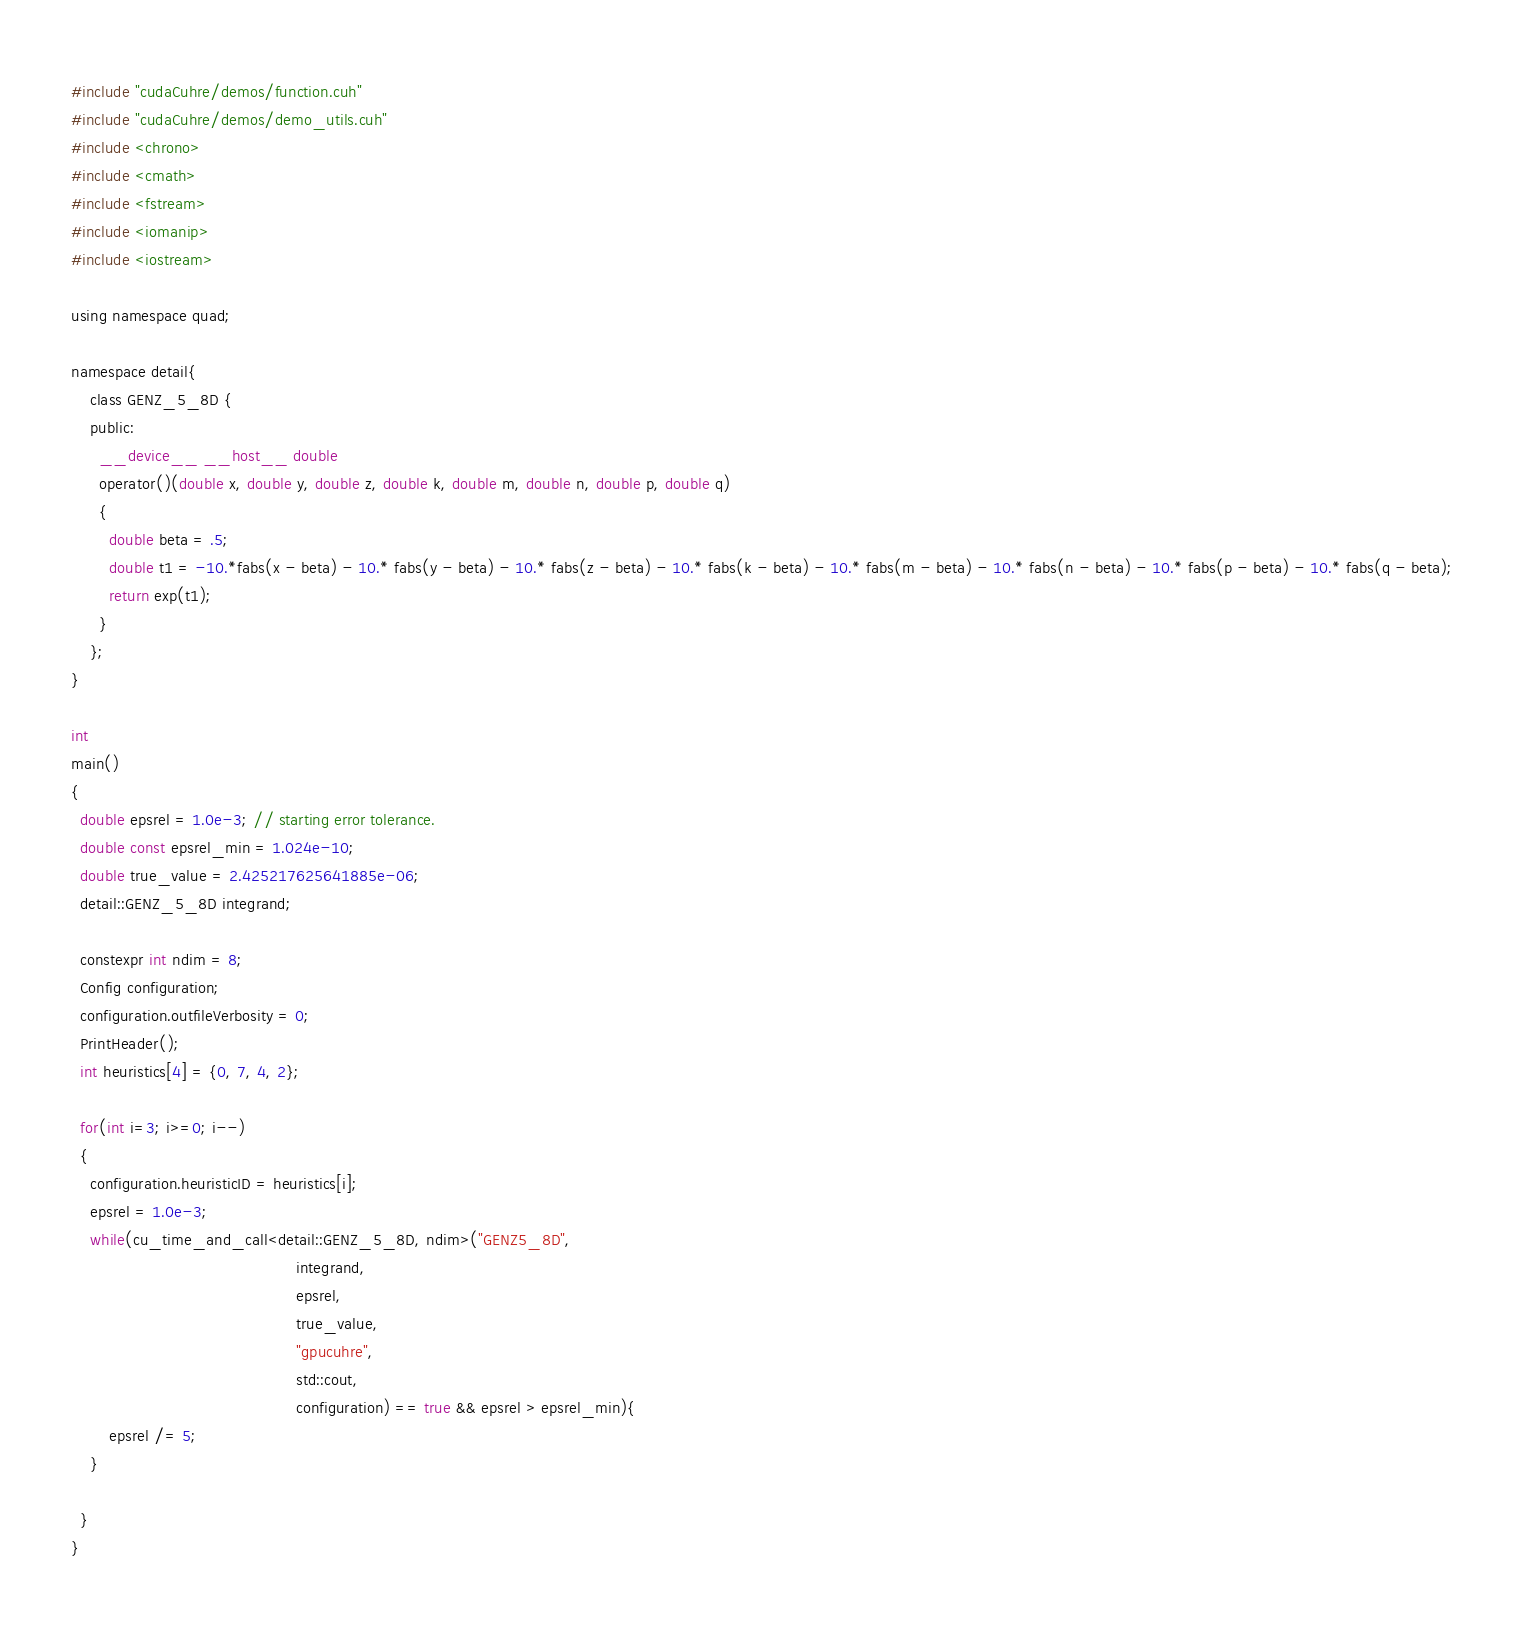<code> <loc_0><loc_0><loc_500><loc_500><_Cuda_>#include "cudaCuhre/demos/function.cuh"
#include "cudaCuhre/demos/demo_utils.cuh"
#include <chrono>
#include <cmath>
#include <fstream>
#include <iomanip>
#include <iostream>

using namespace quad;

namespace detail{
    class GENZ_5_8D {
    public:
      __device__ __host__ double
      operator()(double x, double y, double z, double k, double m, double n, double p, double q)
      {
        double beta = .5;
        double t1 = -10.*fabs(x - beta) - 10.* fabs(y - beta) - 10.* fabs(z - beta) - 10.* fabs(k - beta) - 10.* fabs(m - beta) - 10.* fabs(n - beta) - 10.* fabs(p - beta) - 10.* fabs(q - beta);
        return exp(t1);
      }
    };
}

int
main()
{
  double epsrel = 1.0e-3; // starting error tolerance.
  double const epsrel_min = 1.024e-10;
  double true_value = 2.425217625641885e-06;
  detail::GENZ_5_8D integrand;
  
  constexpr int ndim = 8;
  Config configuration;
  configuration.outfileVerbosity = 0;  
  PrintHeader();
  int heuristics[4] = {0, 7, 4, 2};
 
  for(int i=3; i>=0; i--)
  {
    configuration.heuristicID = heuristics[i];
    epsrel = 1.0e-3;
    while(cu_time_and_call<detail::GENZ_5_8D, ndim>("GENZ5_8D",
                                                integrand,
                                                epsrel,
                                                true_value,
                                                "gpucuhre",
                                                std::cout,
                                                configuration) == true && epsrel > epsrel_min){
        epsrel /= 5;                                                
    }
      
  }
}
</code> 